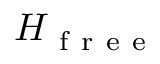Convert formula to latex. <formula><loc_0><loc_0><loc_500><loc_500>H _ { f r e e }</formula> 